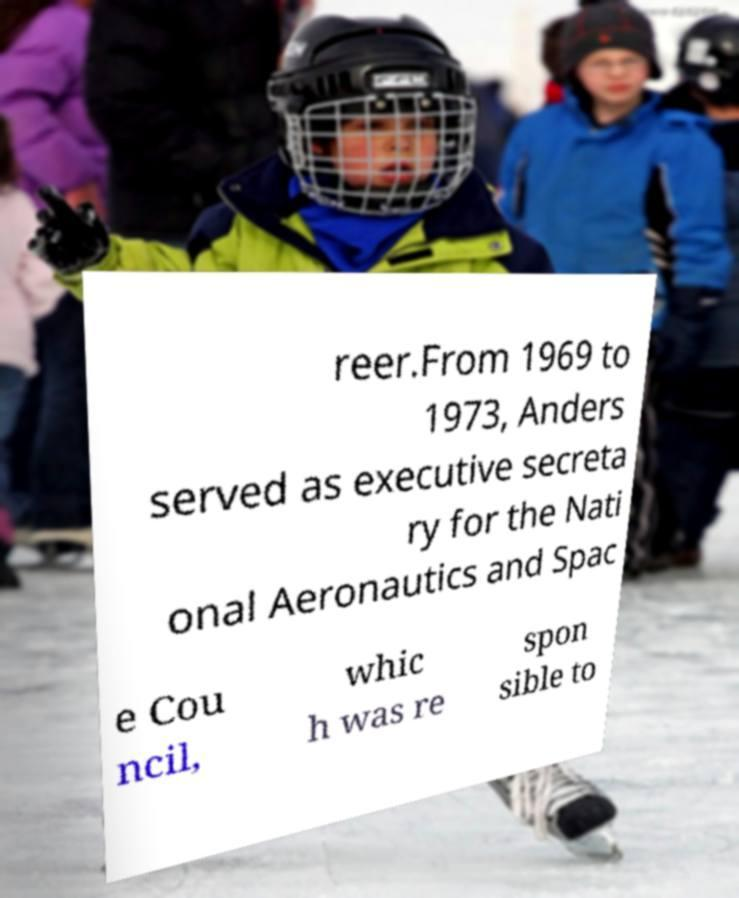I need the written content from this picture converted into text. Can you do that? reer.From 1969 to 1973, Anders served as executive secreta ry for the Nati onal Aeronautics and Spac e Cou ncil, whic h was re spon sible to 